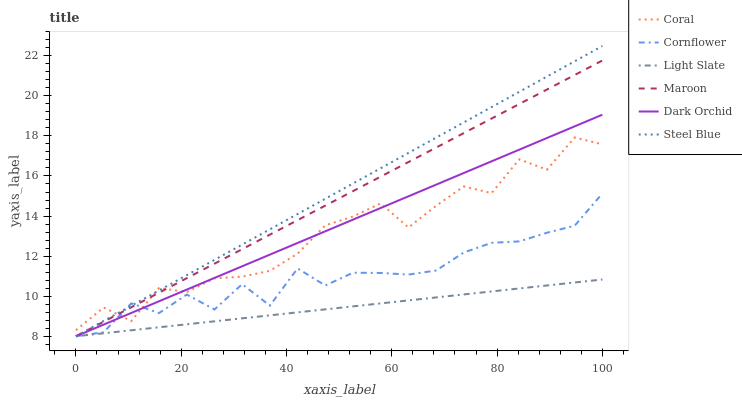Does Light Slate have the minimum area under the curve?
Answer yes or no. Yes. Does Steel Blue have the maximum area under the curve?
Answer yes or no. Yes. Does Coral have the minimum area under the curve?
Answer yes or no. No. Does Coral have the maximum area under the curve?
Answer yes or no. No. Is Dark Orchid the smoothest?
Answer yes or no. Yes. Is Coral the roughest?
Answer yes or no. Yes. Is Light Slate the smoothest?
Answer yes or no. No. Is Light Slate the roughest?
Answer yes or no. No. Does Cornflower have the lowest value?
Answer yes or no. Yes. Does Coral have the lowest value?
Answer yes or no. No. Does Steel Blue have the highest value?
Answer yes or no. Yes. Does Coral have the highest value?
Answer yes or no. No. Is Light Slate less than Coral?
Answer yes or no. Yes. Is Coral greater than Light Slate?
Answer yes or no. Yes. Does Dark Orchid intersect Coral?
Answer yes or no. Yes. Is Dark Orchid less than Coral?
Answer yes or no. No. Is Dark Orchid greater than Coral?
Answer yes or no. No. Does Light Slate intersect Coral?
Answer yes or no. No. 